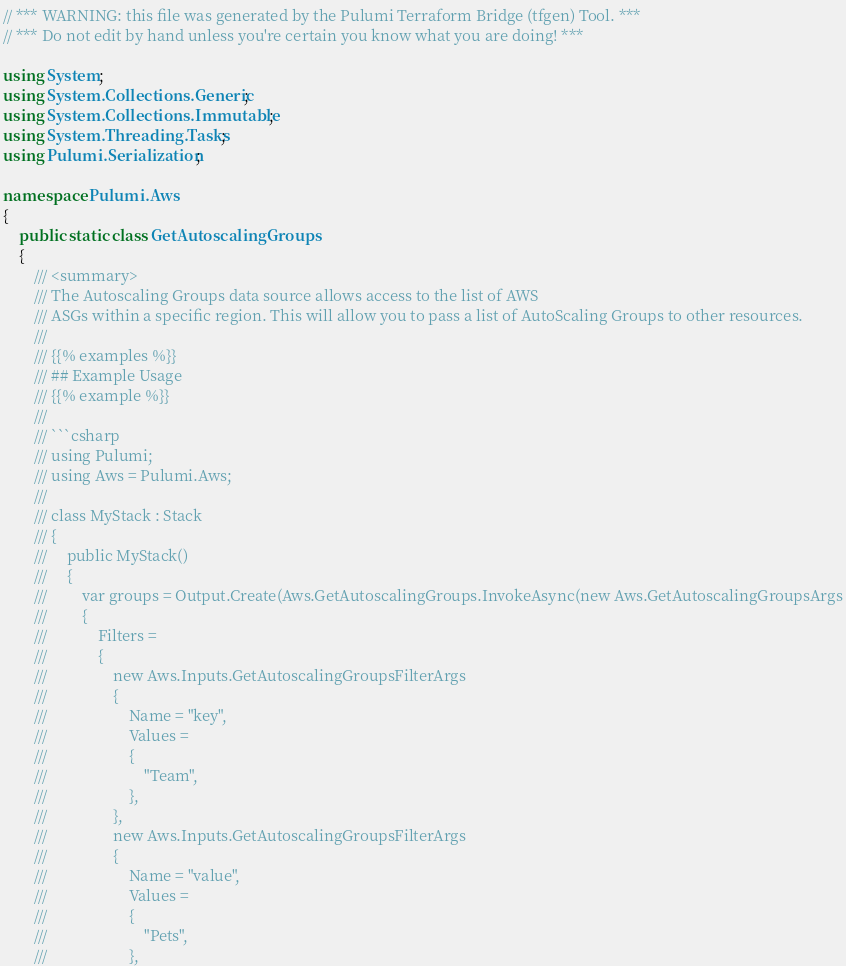Convert code to text. <code><loc_0><loc_0><loc_500><loc_500><_C#_>// *** WARNING: this file was generated by the Pulumi Terraform Bridge (tfgen) Tool. ***
// *** Do not edit by hand unless you're certain you know what you are doing! ***

using System;
using System.Collections.Generic;
using System.Collections.Immutable;
using System.Threading.Tasks;
using Pulumi.Serialization;

namespace Pulumi.Aws
{
    public static class GetAutoscalingGroups
    {
        /// <summary>
        /// The Autoscaling Groups data source allows access to the list of AWS
        /// ASGs within a specific region. This will allow you to pass a list of AutoScaling Groups to other resources.
        /// 
        /// {{% examples %}}
        /// ## Example Usage
        /// {{% example %}}
        /// 
        /// ```csharp
        /// using Pulumi;
        /// using Aws = Pulumi.Aws;
        /// 
        /// class MyStack : Stack
        /// {
        ///     public MyStack()
        ///     {
        ///         var groups = Output.Create(Aws.GetAutoscalingGroups.InvokeAsync(new Aws.GetAutoscalingGroupsArgs
        ///         {
        ///             Filters = 
        ///             {
        ///                 new Aws.Inputs.GetAutoscalingGroupsFilterArgs
        ///                 {
        ///                     Name = "key",
        ///                     Values = 
        ///                     {
        ///                         "Team",
        ///                     },
        ///                 },
        ///                 new Aws.Inputs.GetAutoscalingGroupsFilterArgs
        ///                 {
        ///                     Name = "value",
        ///                     Values = 
        ///                     {
        ///                         "Pets",
        ///                     },</code> 